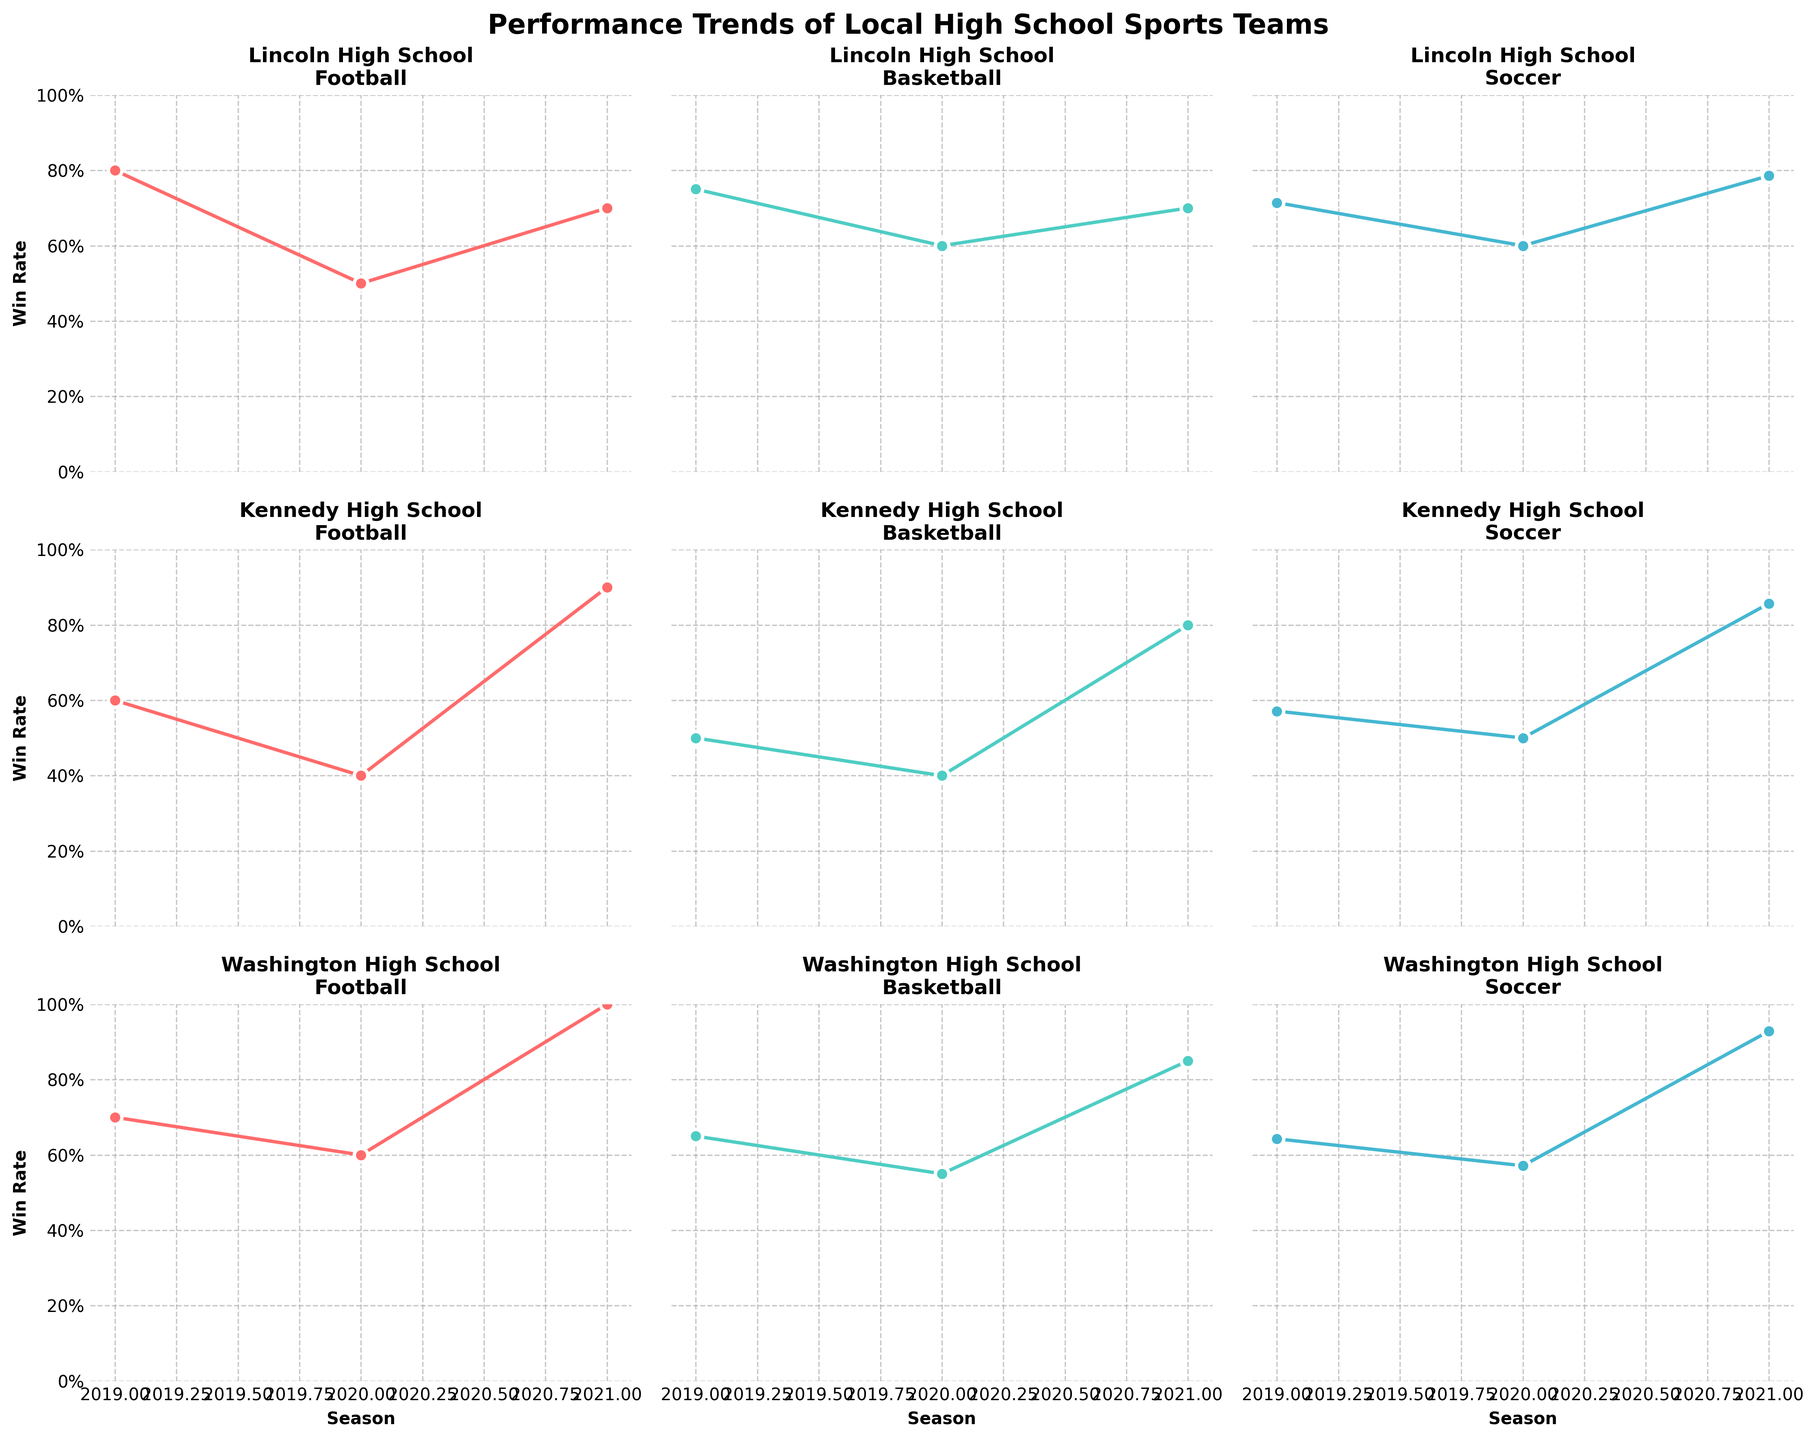What is the title of the figure? The title is typically displayed at the top of the figure.
Answer: Performance Trends of Local High School Sports Teams Which team had an undefeated season in football, and in which year? From the plot, Washington High School's football team shows a 100% win rate in the 2021 season.
Answer: Washington High School, 2021 How does Lincoln High School's basketball win rate in 2019 compare to 2020? Looking at the plot lines for Lincoln High School's basketball team, the win rate is higher in 2019 compared to 2020. This can be seen from the position of the 2019 data point being higher than the 2020 data point.
Answer: Higher What is the range of win rates for Kennedy High School's soccer team across all seasons? Observing the plot lines for Kennedy High School's soccer team, the win rate fluctuates between approximately 50% and 85% across different seasons.
Answer: 50% to 85% Which team's soccer performance improved every year? By examining the soccer plots, each team's trend can be seen. Washington High School's soccer win rate consistently increased from 2019 to 2021.
Answer: Washington High School Which school’s basketball team had the most fluctuation in win rate over the years? Comparing the plots for each team's basketball win rates over the years, Kennedy High School shows the most variability, with noticeable changes each season.
Answer: Kennedy High School How does Kennedy High School's football win rate in 2020 compare to 2021? Looking at the Kennedy High School football plot, the win rate significantly increased from 2020 to 2021, moving from 40% to 90%.
Answer: Increased Which season had the best overall performance for Lincoln High School? To determine this, you need to look at all plots for Lincoln High School across all three sports. 2021 shows higher win rates across each sport compared to other years.
Answer: 2021 What trend is observed in Washington High School’s basketball performance from 2019 to 2021? The trend line for Washington High School's basketball shows a consistent improvement in win rates from 2019 through 2021, indicating a positive trend.
Answer: Improvement 